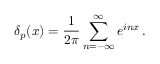<formula> <loc_0><loc_0><loc_500><loc_500>\delta _ { p } ( x ) = \frac { 1 } { 2 \pi } \sum _ { n = - \infty } ^ { \infty } e ^ { i n x } \, .</formula> 